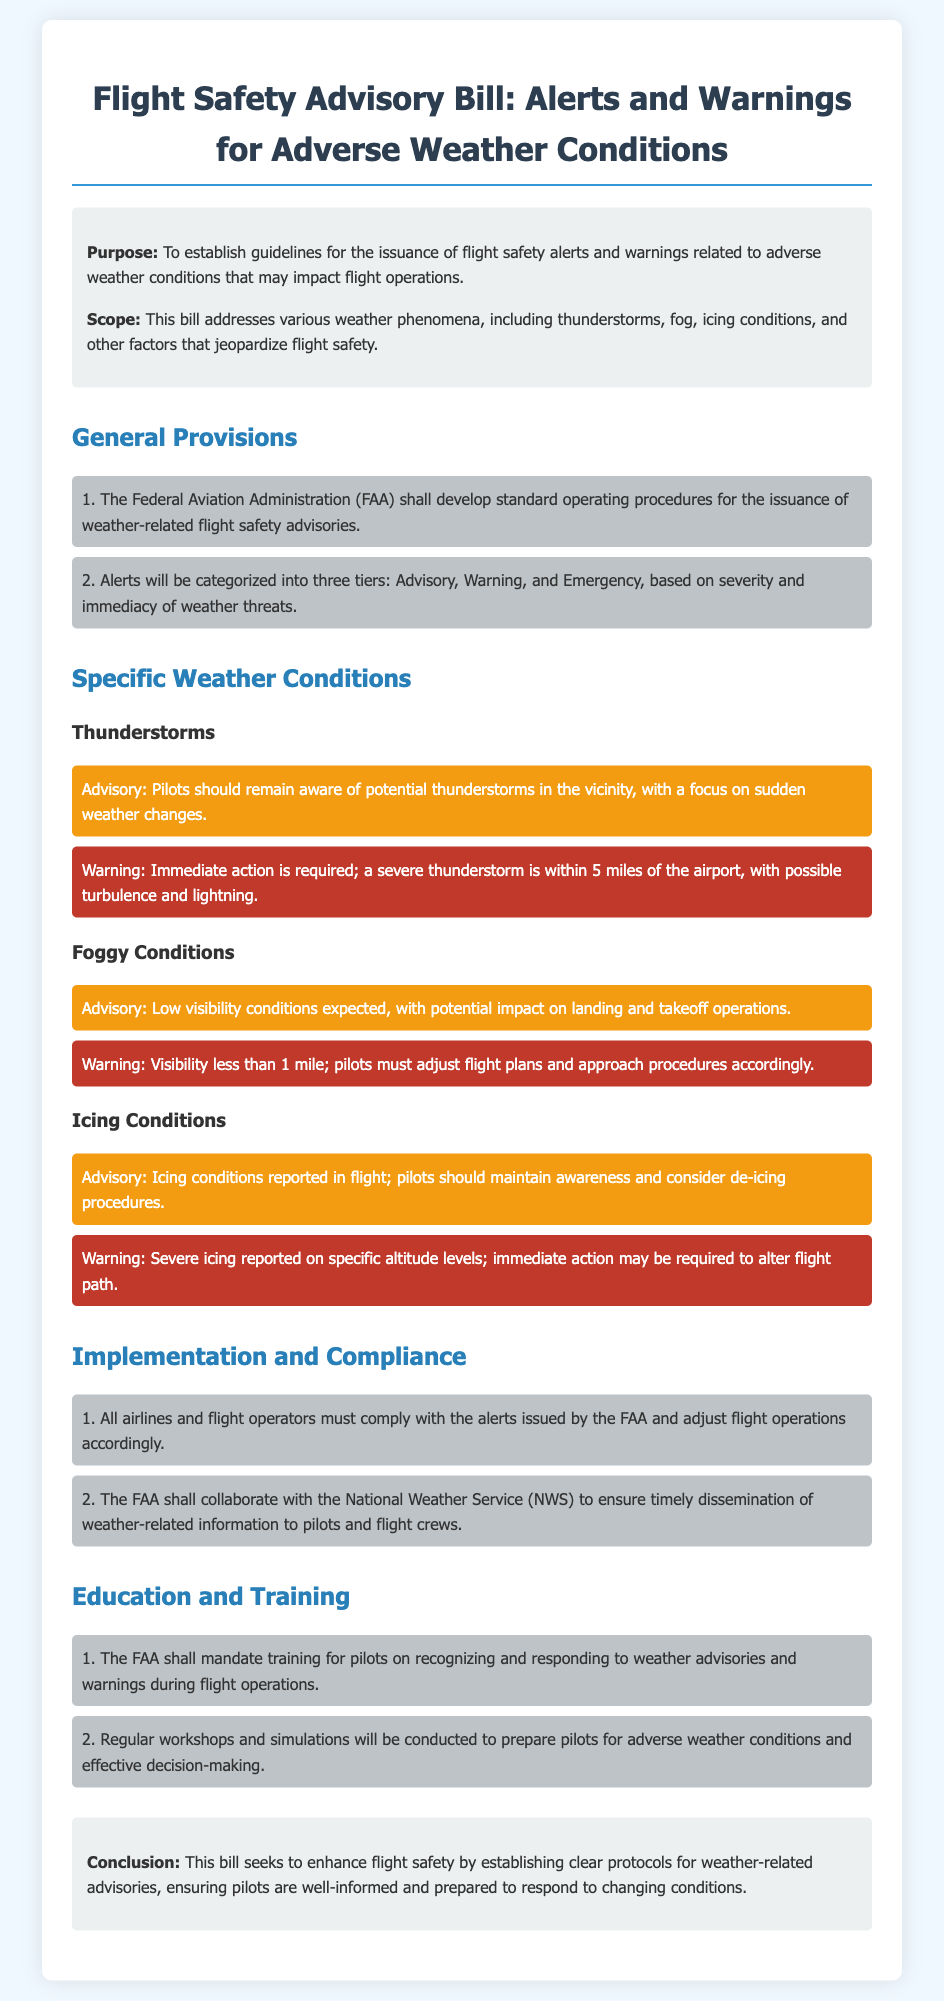What is the title of the bill? The title of the bill is mentioned at the top of the document, which establishes its primary focus.
Answer: Flight Safety Advisory Bill: Alerts and Warnings for Adverse Weather Conditions Who develops standard operating procedures for weather-related advisories? The document specifies that a particular organization is responsible for developing these procedures.
Answer: Federal Aviation Administration (FAA) What are the three tiers of alerts? The tiers of alerts are clearly outlined in the general provisions section of the document, categorized by severity.
Answer: Advisory, Warning, Emergency What should pilots do when a severe thunderstorm is within 5 miles? This is addressed in the specific warnings section related to thunderstorms, indicating the necessary pilot action.
Answer: Immediate action is required What visibility condition must pilots adjust flight plans for? The document specifies a critical visibility threshold that requires pilots to take action.
Answer: Less than 1 mile What type of training will the FAA mandate for pilots? The document describes the type of training that pilots will be required to undergo as part of the safety measures.
Answer: Recognizing and responding to weather advisories and warnings What is the purpose of the bill? The purpose is stated in the introduction section, summarizing the main aims of the legislation.
Answer: To establish guidelines for the issuance of flight safety alerts and warnings What organization collaborates with the FAA for timely information dissemination? The document identifies a specific organization that works alongside the FAA to improve communication about weather-related issues.
Answer: National Weather Service (NWS) 